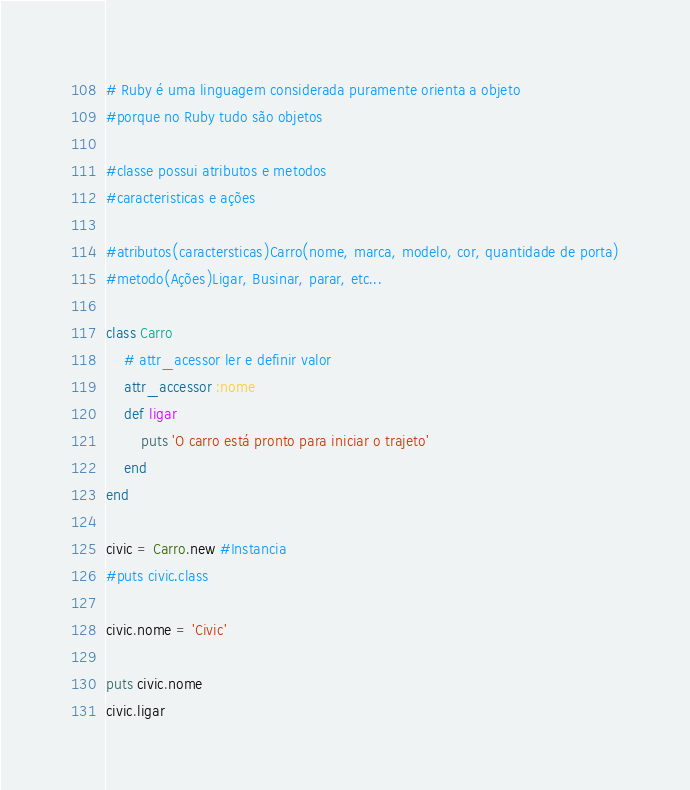Convert code to text. <code><loc_0><loc_0><loc_500><loc_500><_Ruby_># Ruby é uma linguagem considerada puramente orienta a objeto
#porque no Ruby tudo são objetos

#classe possui atributos e metodos
#caracteristicas e ações

#atributos(caractersticas)Carro(nome, marca, modelo, cor, quantidade de porta)
#metodo(Ações)Ligar, Businar, parar, etc...

class Carro
    # attr_acessor ler e definir valor
    attr_accessor :nome
    def ligar
        puts 'O carro está pronto para iniciar o trajeto'
    end
end

civic = Carro.new #Instancia
#puts civic.class 

civic.nome = 'Civic'

puts civic.nome 
civic.ligar
</code> 